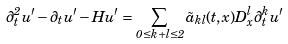Convert formula to latex. <formula><loc_0><loc_0><loc_500><loc_500>\partial _ { t } ^ { 2 } u ^ { \prime } - \partial _ { t } u ^ { \prime } - H u ^ { \prime } = \sum _ { 0 \leq k + l \leq 2 } \tilde { a } _ { k l } ( t , x ) D _ { x } ^ { l } \partial _ { t } ^ { k } u ^ { \prime }</formula> 